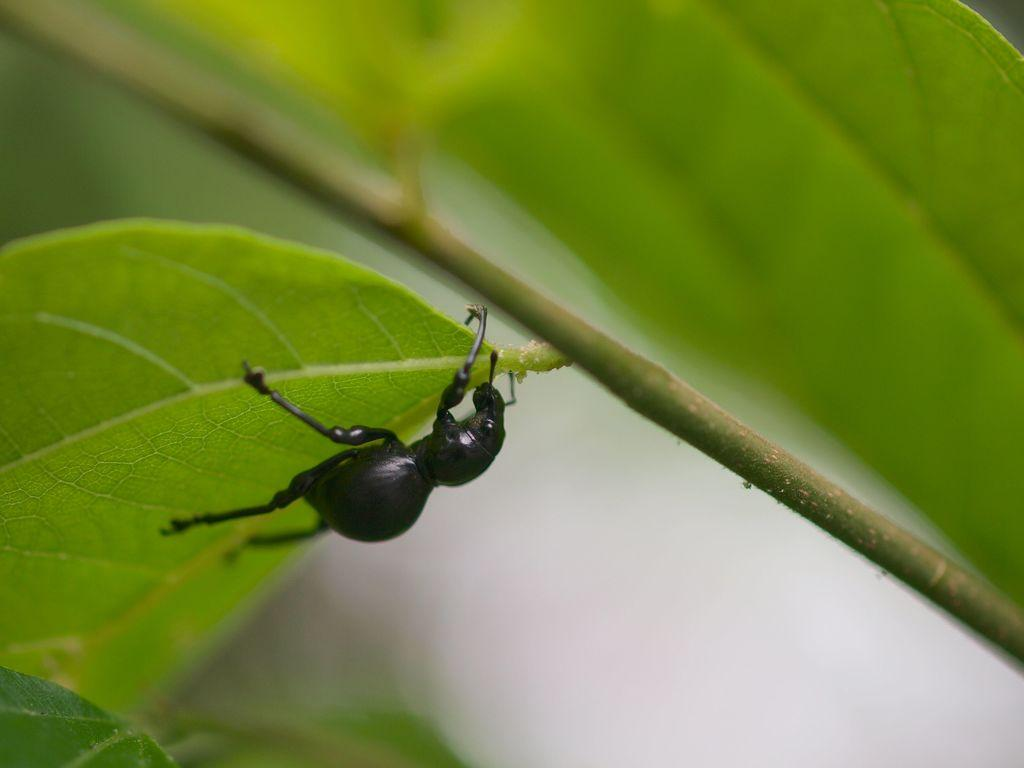What is the main subject in the foreground of the image? There is a black insect in the foreground of the image. Where is the insect located? The insect is on a leaf. Can you describe any other plant elements in the image? There is another leaf connected to a stem in the image. What year is depicted in the image? The image does not depict a specific year; it is a photograph of a black insect on a leaf. 